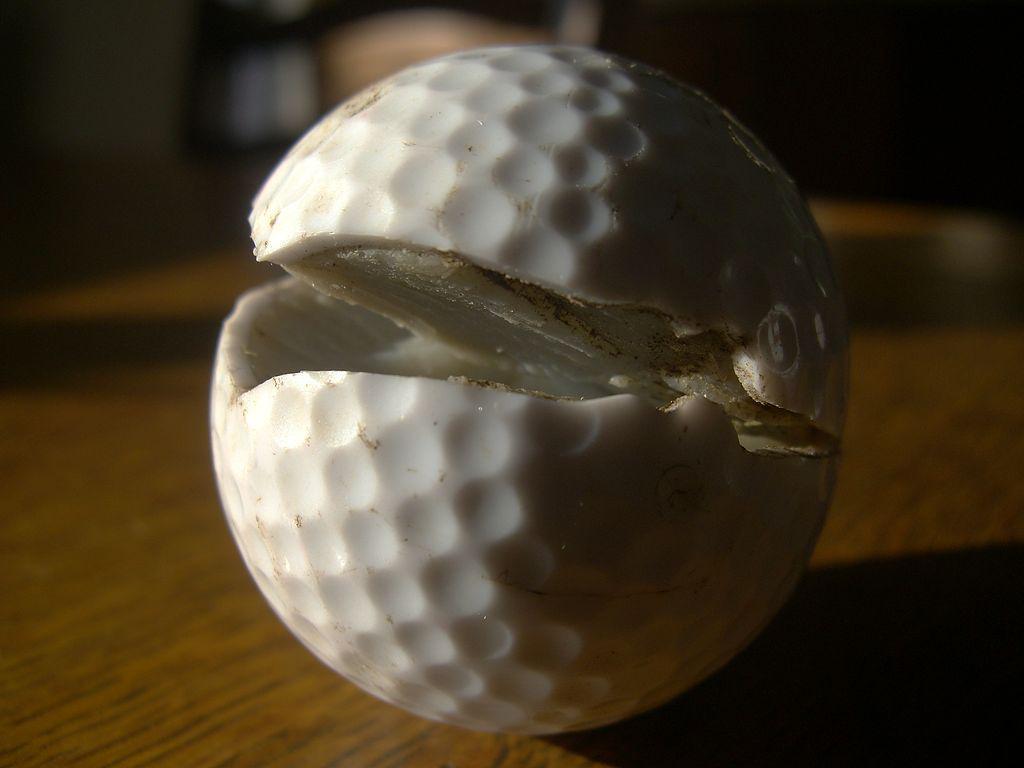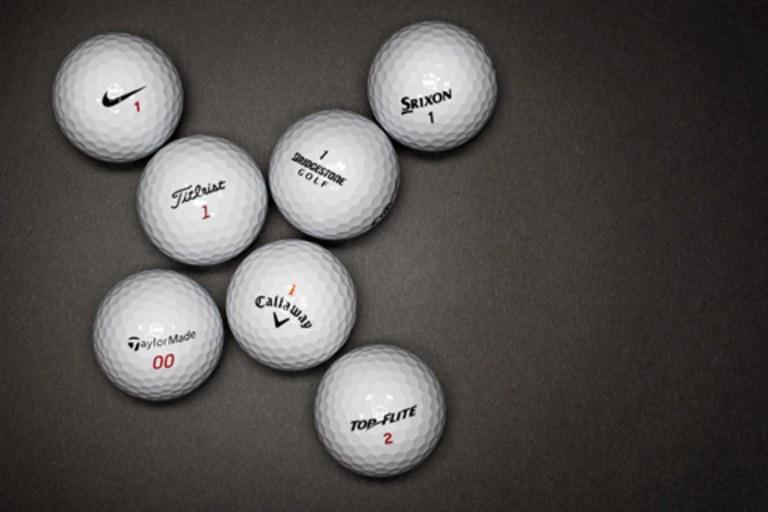The first image is the image on the left, the second image is the image on the right. For the images displayed, is the sentence "The right image contains exactly two golf balls." factually correct? Answer yes or no. No. The first image is the image on the left, the second image is the image on the right. For the images displayed, is the sentence "The right image includes at least one golf tee, and the left image shows a pair of balls side-by-side." factually correct? Answer yes or no. No. 